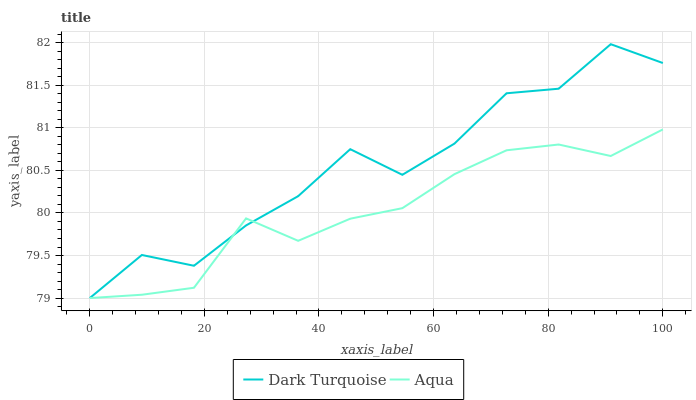Does Aqua have the minimum area under the curve?
Answer yes or no. Yes. Does Dark Turquoise have the maximum area under the curve?
Answer yes or no. Yes. Does Aqua have the maximum area under the curve?
Answer yes or no. No. Is Aqua the smoothest?
Answer yes or no. Yes. Is Dark Turquoise the roughest?
Answer yes or no. Yes. Is Aqua the roughest?
Answer yes or no. No. Does Dark Turquoise have the lowest value?
Answer yes or no. Yes. Does Dark Turquoise have the highest value?
Answer yes or no. Yes. Does Aqua have the highest value?
Answer yes or no. No. Does Dark Turquoise intersect Aqua?
Answer yes or no. Yes. Is Dark Turquoise less than Aqua?
Answer yes or no. No. Is Dark Turquoise greater than Aqua?
Answer yes or no. No. 